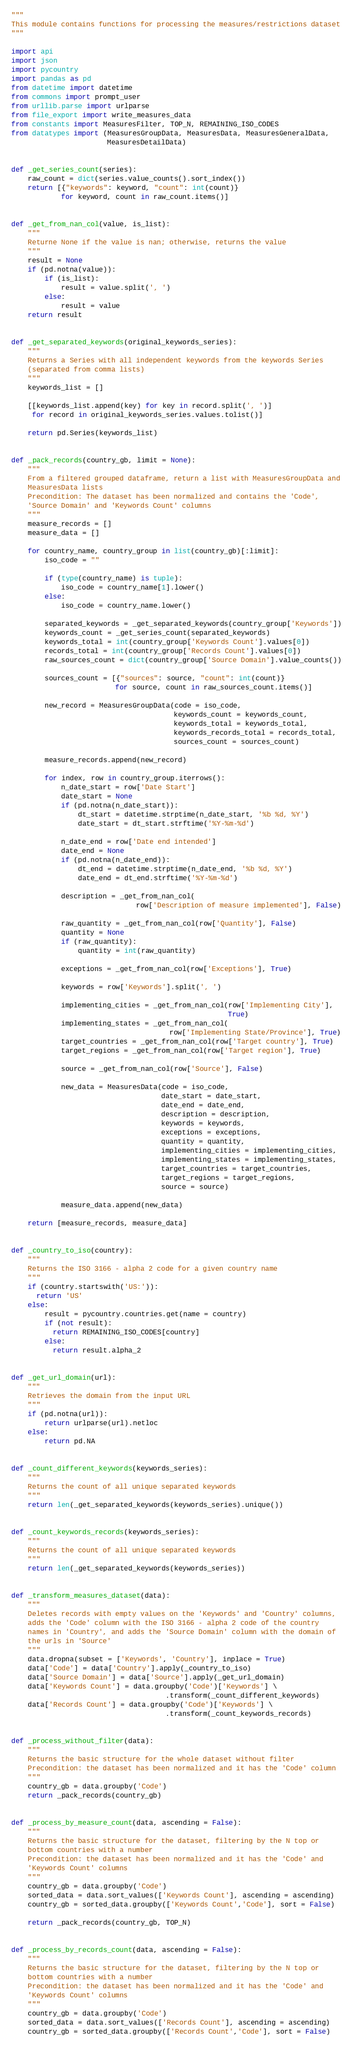Convert code to text. <code><loc_0><loc_0><loc_500><loc_500><_Python_>"""
This module contains functions for processing the measures/restrictions dataset
"""

import api
import json
import pycountry
import pandas as pd
from datetime import datetime
from commons import prompt_user
from urllib.parse import urlparse
from file_export import write_measures_data
from constants import MeasuresFilter, TOP_N, REMAINING_ISO_CODES
from datatypes import (MeasuresGroupData, MeasuresData, MeasuresGeneralData,
                       MeasuresDetailData)


def _get_series_count(series):
    raw_count = dict(series.value_counts().sort_index())
    return [{"keywords": keyword, "count": int(count)}
            for keyword, count in raw_count.items()]


def _get_from_nan_col(value, is_list):
    """
    Returne None if the value is nan; otherwise, returns the value
    """
    result = None
    if (pd.notna(value)):
        if (is_list):
            result = value.split(', ')
        else:
            result = value
    return result


def _get_separated_keywords(original_keywords_series):
    """
    Returns a Series with all independent keywords from the keywords Series
    (separated from comma lists)
    """
    keywords_list = []

    [[keywords_list.append(key) for key in record.split(', ')]
     for record in original_keywords_series.values.tolist()]

    return pd.Series(keywords_list)


def _pack_records(country_gb, limit = None):
    """
    From a filtered grouped dataframe, return a list with MeasuresGroupData and
    MeasuresData lists
    Precondition: The dataset has been normalized and contains the 'Code',
    'Source Domain' and 'Keywords Count' columns
    """
    measure_records = []
    measure_data = []

    for country_name, country_group in list(country_gb)[:limit]:
        iso_code = ""

        if (type(country_name) is tuple):
            iso_code = country_name[1].lower()
        else:
            iso_code = country_name.lower()

        separated_keywords = _get_separated_keywords(country_group['Keywords'])
        keywords_count = _get_series_count(separated_keywords)
        keywords_total = int(country_group['Keywords Count'].values[0])
        records_total = int(country_group['Records Count'].values[0])
        raw_sources_count = dict(country_group['Source Domain'].value_counts())

        sources_count = [{"sources": source, "count": int(count)}
                         for source, count in raw_sources_count.items()]

        new_record = MeasuresGroupData(code = iso_code,
                                       keywords_count = keywords_count,
                                       keywords_total = keywords_total,
                                       keywords_records_total = records_total,
                                       sources_count = sources_count)

        measure_records.append(new_record)

        for index, row in country_group.iterrows():
            n_date_start = row['Date Start']
            date_start = None
            if (pd.notna(n_date_start)):
                dt_start = datetime.strptime(n_date_start, '%b %d, %Y')
                date_start = dt_start.strftime('%Y-%m-%d')

            n_date_end = row['Date end intended']
            date_end = None
            if (pd.notna(n_date_end)):
                dt_end = datetime.strptime(n_date_end, '%b %d, %Y')
                date_end = dt_end.strftime('%Y-%m-%d')

            description = _get_from_nan_col(
                              row['Description of measure implemented'], False)

            raw_quantity = _get_from_nan_col(row['Quantity'], False)
            quantity = None
            if (raw_quantity):
                quantity = int(raw_quantity)
                              
            exceptions = _get_from_nan_col(row['Exceptions'], True)

            keywords = row['Keywords'].split(', ')

            implementing_cities = _get_from_nan_col(row['Implementing City'],
                                                    True)
            implementing_states = _get_from_nan_col(
                                      row['Implementing State/Province'], True)
            target_countries = _get_from_nan_col(row['Target country'], True)
            target_regions = _get_from_nan_col(row['Target region'], True)

            source = _get_from_nan_col(row['Source'], False)

            new_data = MeasuresData(code = iso_code,
                                    date_start = date_start,
                                    date_end = date_end,
                                    description = description,
                                    keywords = keywords,
                                    exceptions = exceptions,
                                    quantity = quantity,
                                    implementing_cities = implementing_cities,
                                    implementing_states = implementing_states,
                                    target_countries = target_countries,
                                    target_regions = target_regions,
                                    source = source)

            measure_data.append(new_data)

    return [measure_records, measure_data]


def _country_to_iso(country):
    """
    Returns the ISO 3166 - alpha 2 code for a given country name
    """
    if (country.startswith('US:')):
      return 'US'
    else:
        result = pycountry.countries.get(name = country)
        if (not result):
          return REMAINING_ISO_CODES[country]
        else:
          return result.alpha_2


def _get_url_domain(url):
    """
    Retrieves the domain from the input URL
    """
    if (pd.notna(url)):
        return urlparse(url).netloc
    else:
        return pd.NA


def _count_different_keywords(keywords_series):
    """
    Returns the count of all unique separated keywords 
    """
    return len(_get_separated_keywords(keywords_series).unique())


def _count_keywords_records(keywords_series):
    """
    Returns the count of all unique separated keywords 
    """
    return len(_get_separated_keywords(keywords_series))


def _transform_measures_dataset(data):
    """
    Deletes records with empty values on the 'Keywords' and 'Country' columns,
    adds the 'Code' column with the ISO 3166 - alpha 2 code of the country
    names in 'Country', and adds the 'Source Domain' column with the domain of
    the urls in 'Source'
    """
    data.dropna(subset = ['Keywords', 'Country'], inplace = True)
    data['Code'] = data['Country'].apply(_country_to_iso)
    data['Source Domain'] = data['Source'].apply(_get_url_domain)
    data['Keywords Count'] = data.groupby('Code')['Keywords'] \
                                     .transform(_count_different_keywords)
    data['Records Count'] = data.groupby('Code')['Keywords'] \
                                     .transform(_count_keywords_records)


def _process_without_filter(data):
    """
    Returns the basic structure for the whole dataset without filter
    Precondition: the dataset has been normalized and it has the 'Code' column
    """
    country_gb = data.groupby('Code')
    return _pack_records(country_gb)


def _process_by_measure_count(data, ascending = False):
    """
    Returns the basic structure for the dataset, filtering by the N top or
    bottom countries with a number 
    Precondition: the dataset has been normalized and it has the 'Code' and
    'Keywords Count' columns
    """
    country_gb = data.groupby('Code')
    sorted_data = data.sort_values(['Keywords Count'], ascending = ascending)
    country_gb = sorted_data.groupby(['Keywords Count','Code'], sort = False)

    return _pack_records(country_gb, TOP_N)


def _process_by_records_count(data, ascending = False):
    """
    Returns the basic structure for the dataset, filtering by the N top or
    bottom countries with a number 
    Precondition: the dataset has been normalized and it has the 'Code' and
    'Keywords Count' columns
    """
    country_gb = data.groupby('Code')
    sorted_data = data.sort_values(['Records Count'], ascending = ascending)
    country_gb = sorted_data.groupby(['Records Count','Code'], sort = False)
</code> 